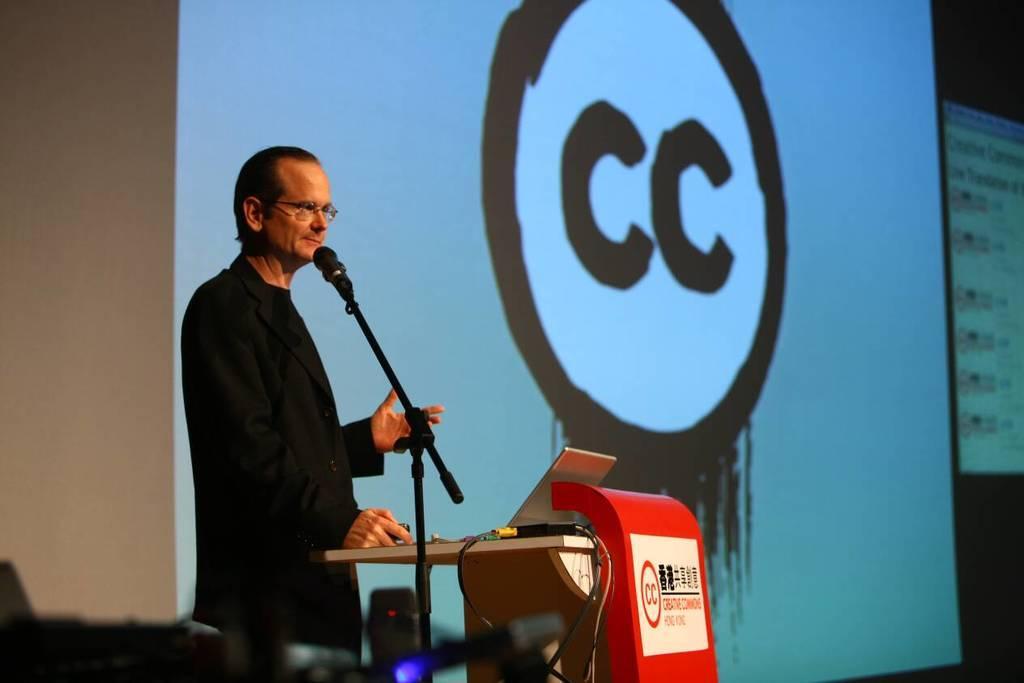Could you give a brief overview of what you see in this image? In the image we can see a man standing, wearing clothes and spectacles. Here we can see podium, microphone and cable wires. Here we can see projected screen and the wall. 